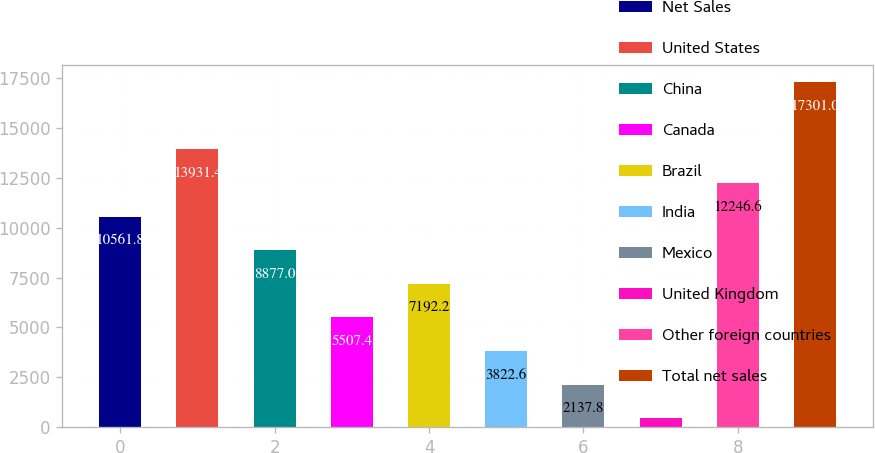<chart> <loc_0><loc_0><loc_500><loc_500><bar_chart><fcel>Net Sales<fcel>United States<fcel>China<fcel>Canada<fcel>Brazil<fcel>India<fcel>Mexico<fcel>United Kingdom<fcel>Other foreign countries<fcel>Total net sales<nl><fcel>10561.8<fcel>13931.4<fcel>8877<fcel>5507.4<fcel>7192.2<fcel>3822.6<fcel>2137.8<fcel>453<fcel>12246.6<fcel>17301<nl></chart> 